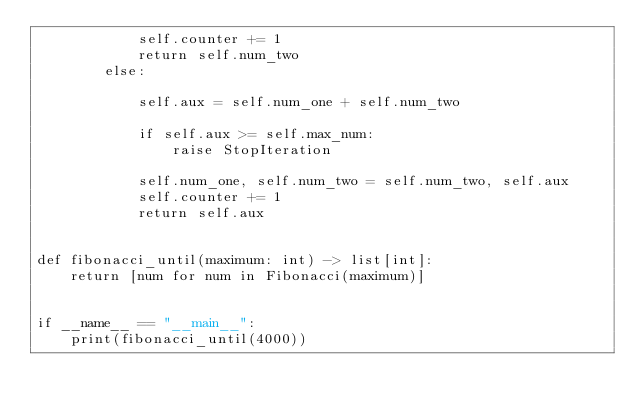Convert code to text. <code><loc_0><loc_0><loc_500><loc_500><_Python_>            self.counter += 1
            return self.num_two
        else:

            self.aux = self.num_one + self.num_two

            if self.aux >= self.max_num:
                raise StopIteration

            self.num_one, self.num_two = self.num_two, self.aux
            self.counter += 1
            return self.aux


def fibonacci_until(maximum: int) -> list[int]:
    return [num for num in Fibonacci(maximum)]


if __name__ == "__main__":
    print(fibonacci_until(4000))
</code> 